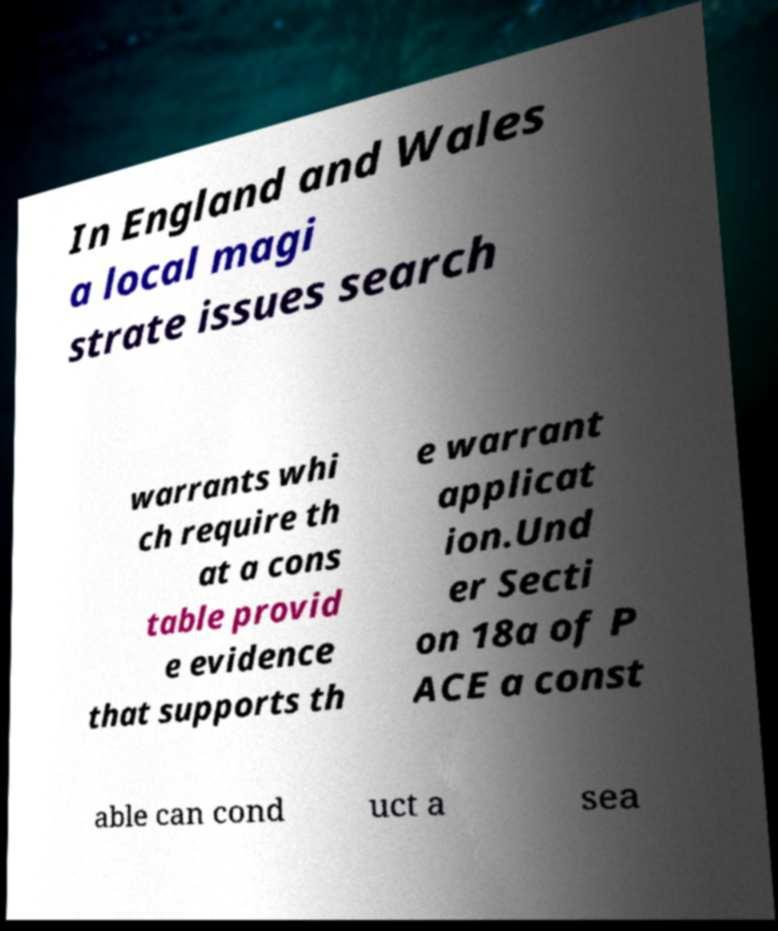Could you assist in decoding the text presented in this image and type it out clearly? In England and Wales a local magi strate issues search warrants whi ch require th at a cons table provid e evidence that supports th e warrant applicat ion.Und er Secti on 18a of P ACE a const able can cond uct a sea 